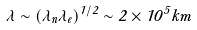Convert formula to latex. <formula><loc_0><loc_0><loc_500><loc_500>\lambda \sim ( \lambda _ { n } \lambda _ { e } ) ^ { 1 / 2 } \sim 2 \times 1 0 ^ { 5 } k m</formula> 